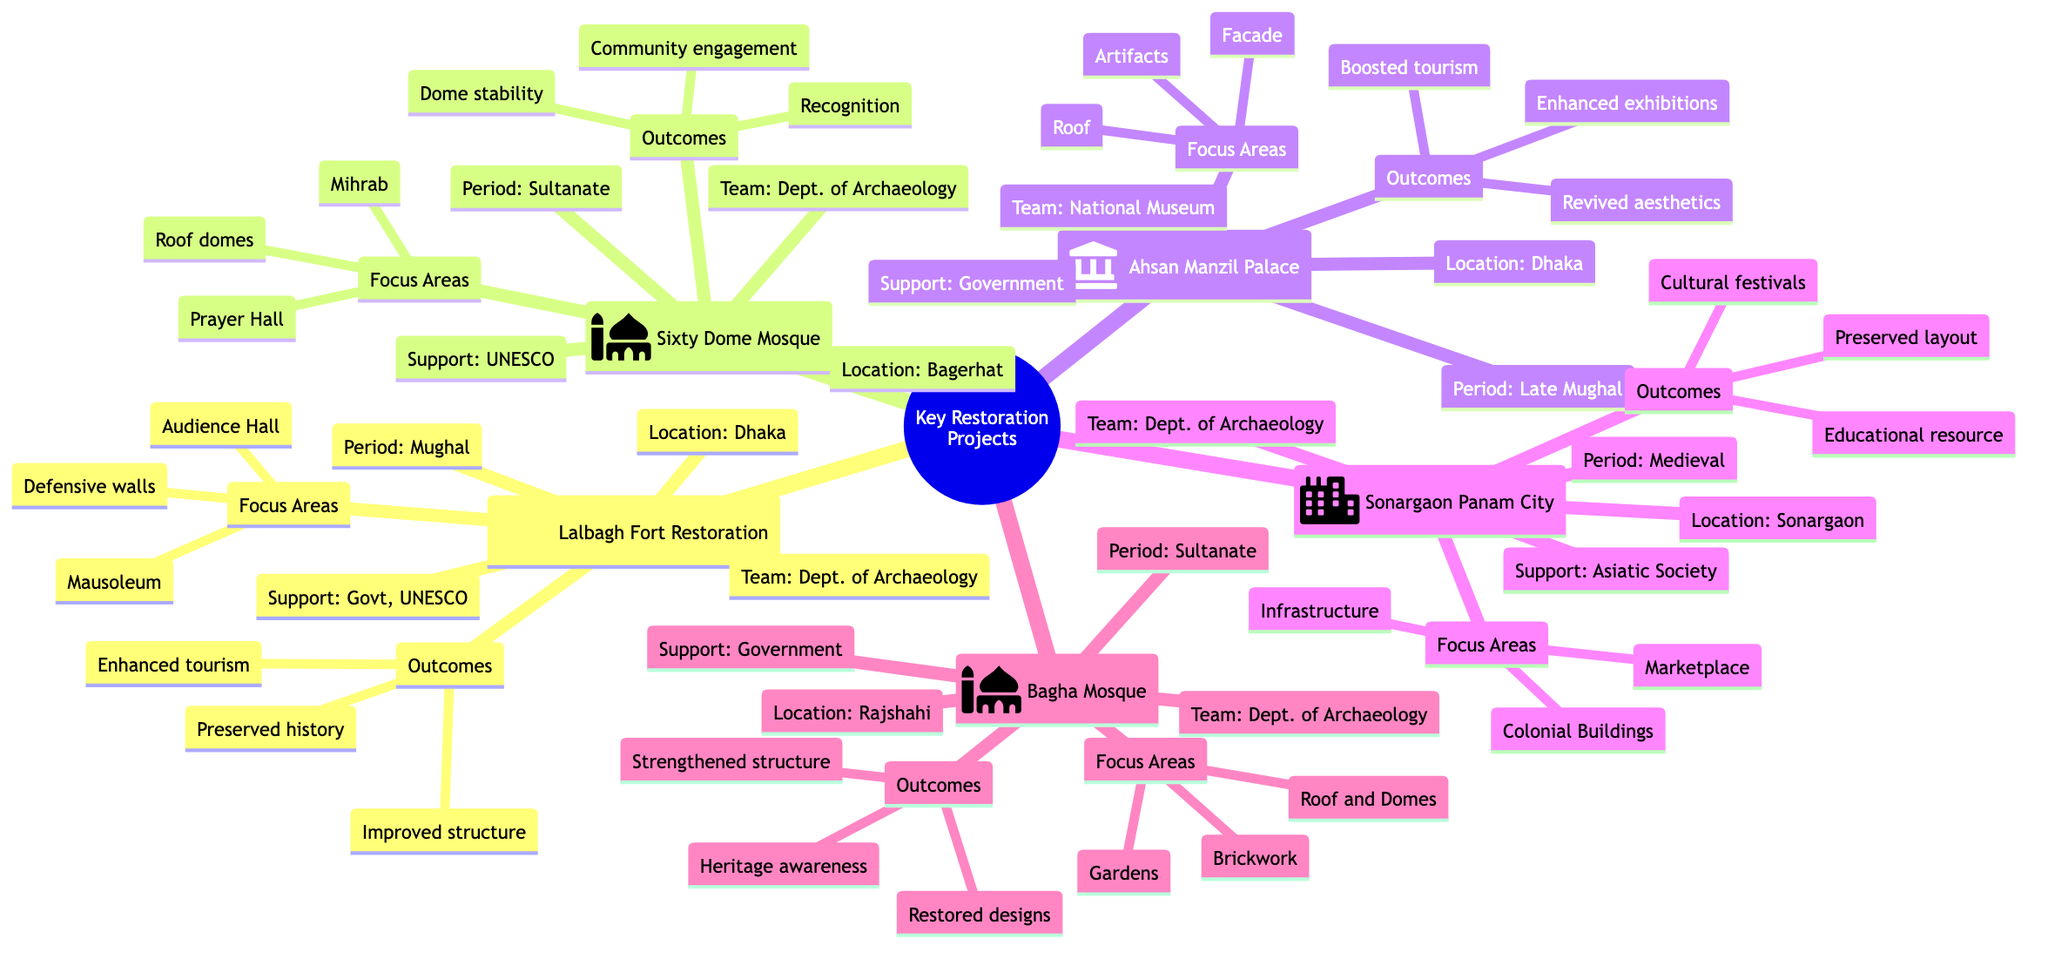What is the location of the Lalbagh Fort Restoration project? The diagram clearly states that the Lalbagh Fort Restoration is located in Dhaka, Bangladesh. This information is provided under the project details for Lalbagh Fort Restoration.
Answer: Dhaka Which restoration project has received support from UNESCO World Heritage Fund? The diagram shows the Sixty Dome Mosque Conservation project, which is highlighted as receiving financial support from the UNESCO World Heritage Fund. This information is directly mentioned under the project's financial support section.
Answer: Sixty Dome Mosque Conservation How many focus areas are listed for the Ahsan Manzil Palace Restoration? In the diagram for Ahsan Manzil Palace Restoration, three focus areas are clearly indicated: Facade Restoration, Roof Repairs, and Interior Artifacts. By counting these items listed in the diagram, we find there are three.
Answer: 3 What is one outcome of the Sonargaon Panam City Restoration? The diagram mentions three outcomes for the Sonargaon Panam City Restoration, one of which is "Preserved historical urban layout." This information is explicitly provided under the outcomes section of the project.
Answer: Preserved historical urban layout Which restoration project focuses on roof domes, prayer hall columns, and mihrab conservation? The diagram specifies that the Sixty Dome Mosque Conservation project has these as its focus areas. This detail is explicitly listed under the project information.
Answer: Sixty Dome Mosque Conservation What is the financial support source for the Bagha Mosque Conservation? According to the diagram, the financial support for the Bagha Mosque Conservation comes from the Government of Bangladesh. This information is presented in the financial support part of the project's details.
Answer: Government of Bangladesh How many restoration projects are listed in total? The diagram lists five separate restoration projects: Lalbagh Fort Restoration, Sixty Dome Mosque Conservation, Ahsan Manzil Palace Restoration, Sonargaon Panam City Restoration, and Bagha Mosque Conservation. By simply counting these projects in the diagram, the total comes to five.
Answer: 5 Which project was restored by the National Museum? The Ahsan Manzil Palace Restoration is specified in the diagram as the project restored by the Bangladesh National Museum. This information is directly included under the project details' restoration team section.
Answer: Ahsan Manzil Palace Restoration What is a common outcome among several restoration projects mentioned? Common outcomes listed for multiple projects include "Enhanced tourist attraction" which is mentioned specifically under the Lalbagh Fort Restoration, and "Increased national and international recognition" in the Sixty Dome Mosque project. Both reflect the broader impact of restoration projects on tourism and recognition.
Answer: Enhanced tourist attraction 